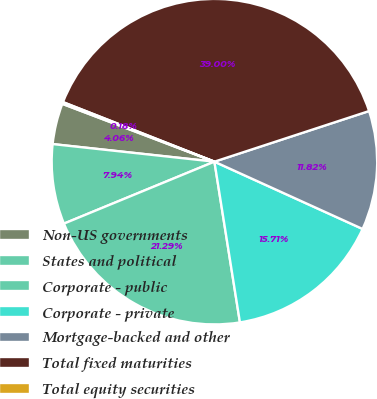Convert chart to OTSL. <chart><loc_0><loc_0><loc_500><loc_500><pie_chart><fcel>Non-US governments<fcel>States and political<fcel>Corporate - public<fcel>Corporate - private<fcel>Mortgage-backed and other<fcel>Total fixed maturities<fcel>Total equity securities<nl><fcel>4.06%<fcel>7.94%<fcel>21.29%<fcel>15.71%<fcel>11.82%<fcel>39.0%<fcel>0.18%<nl></chart> 